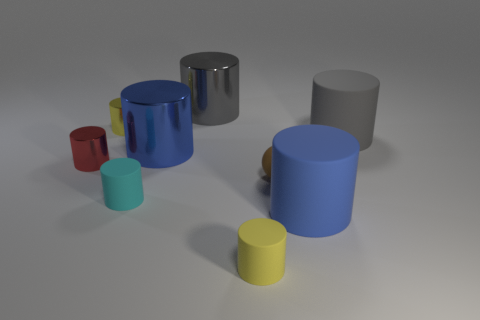Subtract all blue balls. How many yellow cylinders are left? 2 Subtract all tiny cyan cylinders. How many cylinders are left? 7 Subtract all yellow cylinders. How many cylinders are left? 6 Add 1 yellow metallic objects. How many objects exist? 10 Subtract 5 cylinders. How many cylinders are left? 3 Subtract all spheres. How many objects are left? 8 Subtract all blue cylinders. Subtract all gray cubes. How many cylinders are left? 6 Add 3 large gray rubber things. How many large gray rubber things are left? 4 Add 5 tiny rubber balls. How many tiny rubber balls exist? 6 Subtract 1 gray cylinders. How many objects are left? 8 